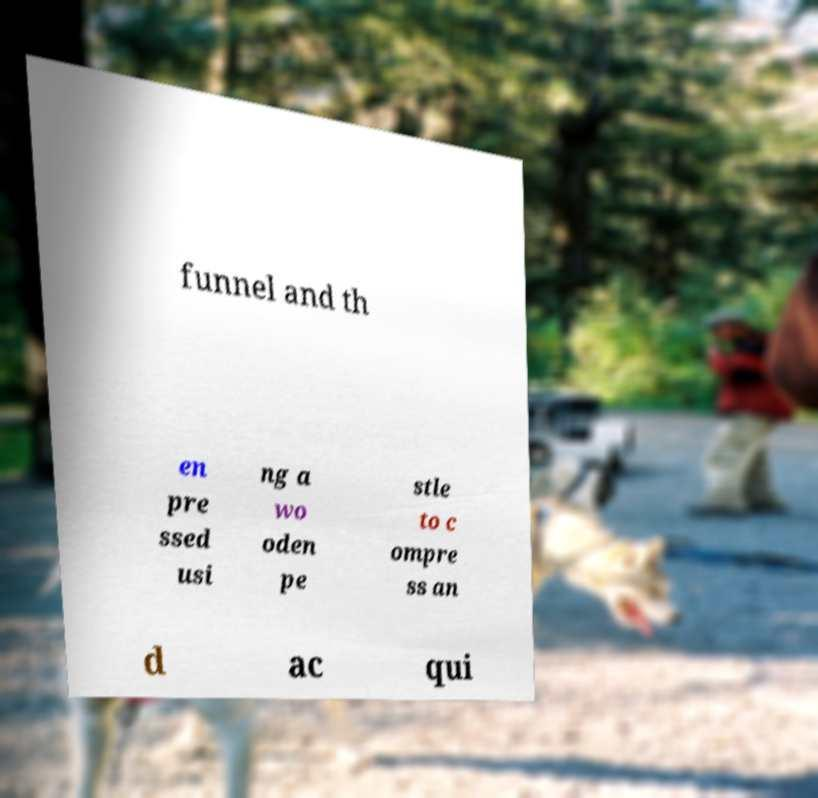For documentation purposes, I need the text within this image transcribed. Could you provide that? funnel and th en pre ssed usi ng a wo oden pe stle to c ompre ss an d ac qui 